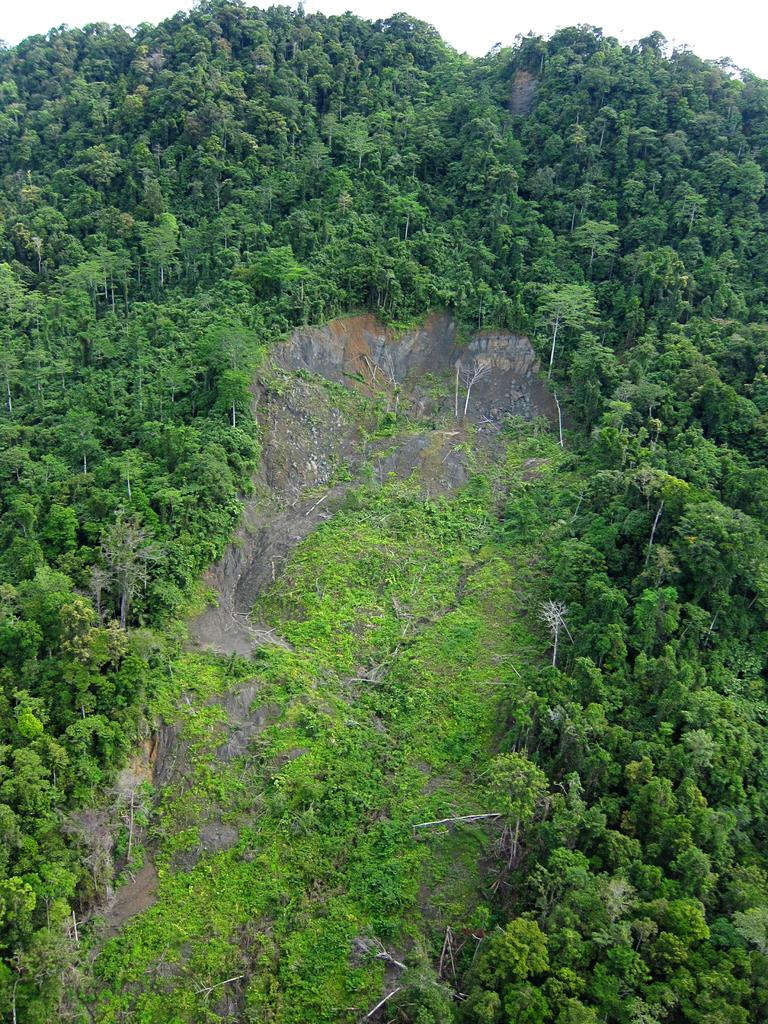What type of landscape is depicted in the image? The image features trees on a hill. Can you describe any specific objects in the image? There is a rock in the image. What type of copper material can be seen in the image? There is no copper material present in the image. How do the waves interact with the trees on the hill in the image? There are no waves present in the image; it features trees on a hill and a rock. 